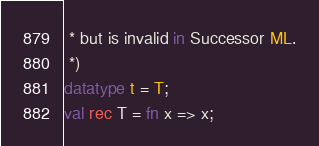<code> <loc_0><loc_0><loc_500><loc_500><_SML_> * but is invalid in Successor ML.
 *)
datatype t = T;
val rec T = fn x => x;
</code> 